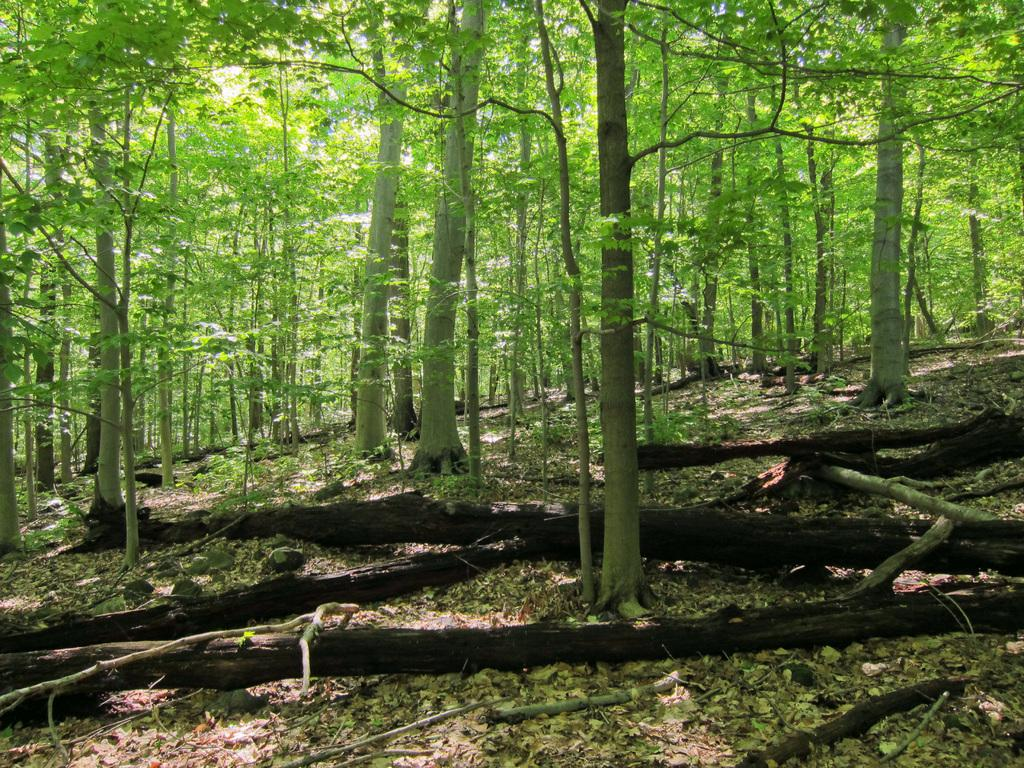What type of objects are made of wood in the image? There are wooden trunks in the image. What type of natural elements are present in the image? There are trees and plants in the image. How many pizzas can be seen on the wooden trunks in the image? There are no pizzas present in the image; it features wooden trunks, trees, and plants. Is there a man using a yoke to carry the wooden trunks in the image? There is no man or yoke present in the image. 